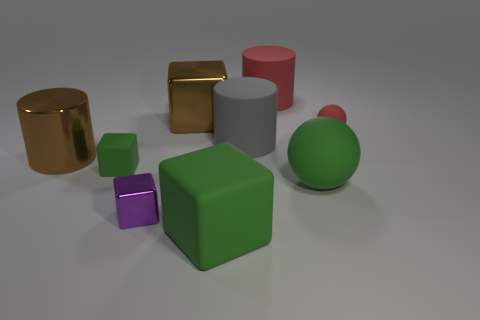Subtract 1 blocks. How many blocks are left? 3 Subtract all cylinders. How many objects are left? 6 Add 3 big brown metallic cubes. How many big brown metallic cubes are left? 4 Add 3 big balls. How many big balls exist? 4 Subtract 0 blue cylinders. How many objects are left? 9 Subtract all cubes. Subtract all large red rubber things. How many objects are left? 4 